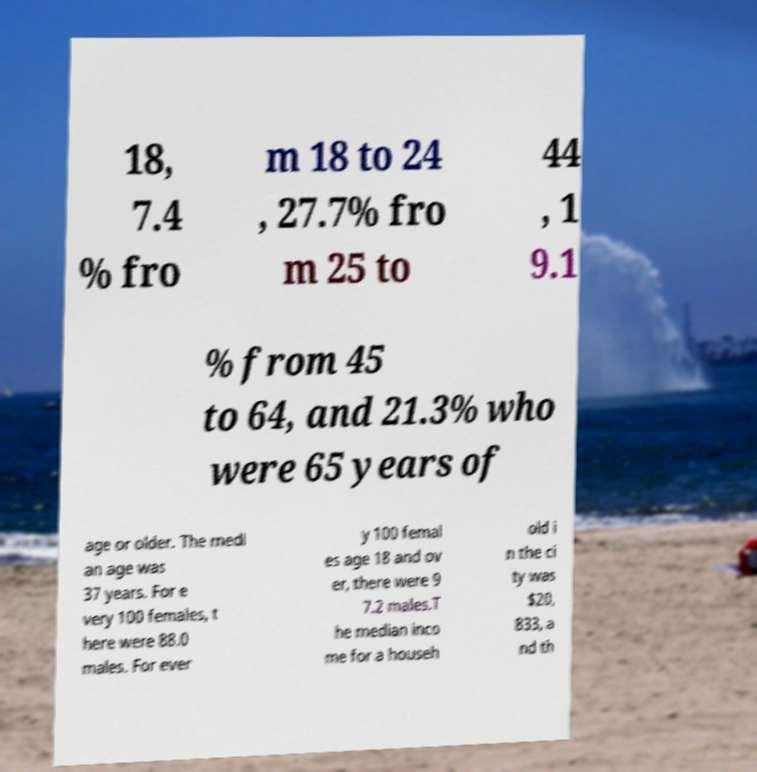Could you extract and type out the text from this image? 18, 7.4 % fro m 18 to 24 , 27.7% fro m 25 to 44 , 1 9.1 % from 45 to 64, and 21.3% who were 65 years of age or older. The medi an age was 37 years. For e very 100 females, t here were 88.0 males. For ever y 100 femal es age 18 and ov er, there were 9 7.2 males.T he median inco me for a househ old i n the ci ty was $20, 833, a nd th 